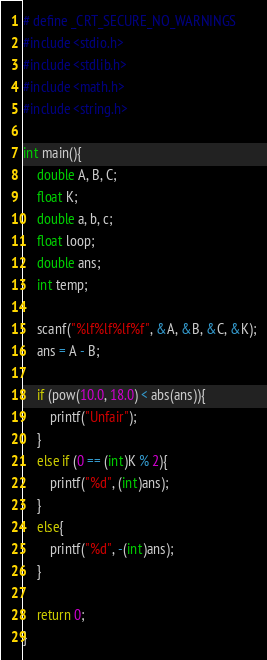Convert code to text. <code><loc_0><loc_0><loc_500><loc_500><_C_># define _CRT_SECURE_NO_WARNINGS
#include <stdio.h>
#include <stdlib.h>
#include <math.h>
#include <string.h>

int main(){
    double A, B, C;
    float K;
    double a, b, c;
    float loop;
    double ans;
    int temp;

    scanf("%lf%lf%lf%f", &A, &B, &C, &K);
    ans = A - B;

    if (pow(10.0, 18.0) < abs(ans)){
        printf("Unfair");
    }
    else if (0 == (int)K % 2){
        printf("%d", (int)ans);
    }
    else{
        printf("%d", -(int)ans);
    }

    return 0;
}</code> 